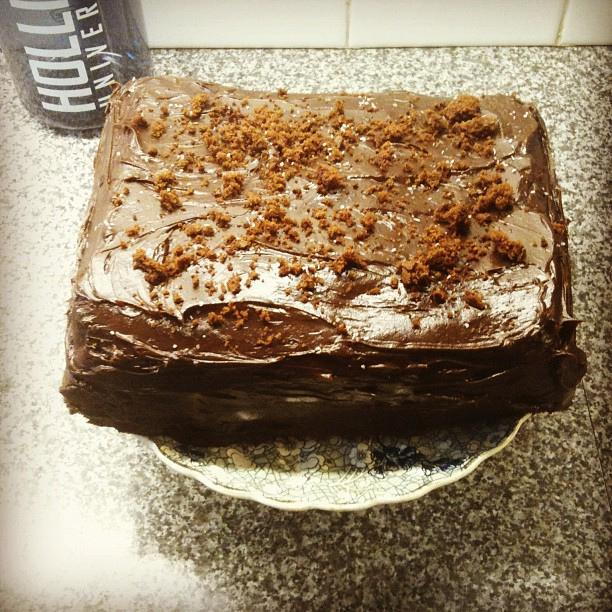What would this food item be ideal for? Please explain your reasoning. birthday. The cake is chocolate. 